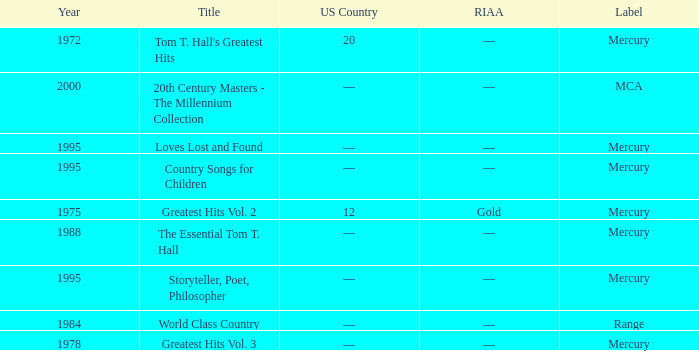What label had the album after 1978? Range, Mercury, Mercury, Mercury, Mercury, MCA. 